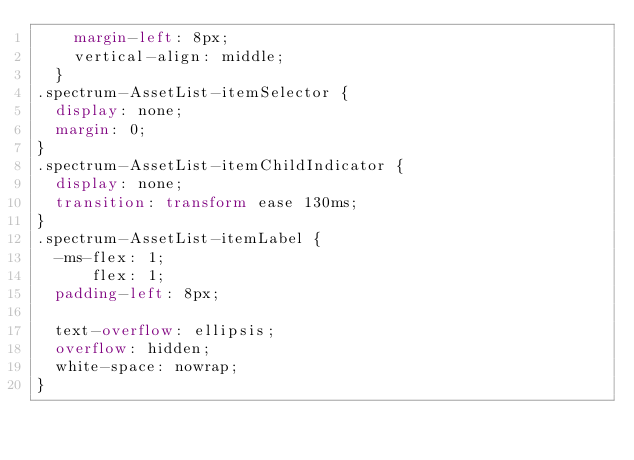Convert code to text. <code><loc_0><loc_0><loc_500><loc_500><_CSS_>    margin-left: 8px;
    vertical-align: middle;
  }
.spectrum-AssetList-itemSelector {
  display: none;
  margin: 0;
}
.spectrum-AssetList-itemChildIndicator {
  display: none;
  transition: transform ease 130ms;
}
.spectrum-AssetList-itemLabel {
  -ms-flex: 1;
      flex: 1;
  padding-left: 8px;

  text-overflow: ellipsis;
  overflow: hidden;
  white-space: nowrap;
}
</code> 